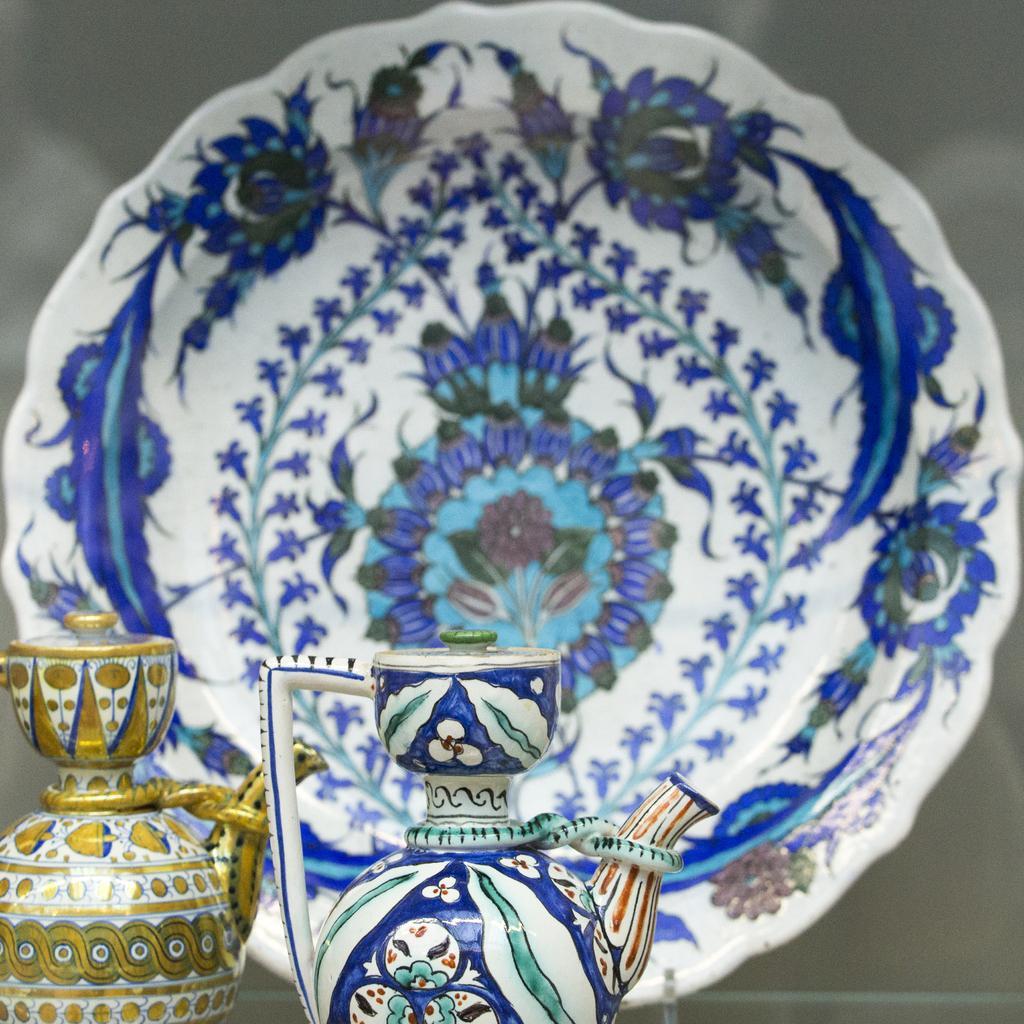How would you summarize this image in a sentence or two? In this image we can see jars and a plate placed on the table. 